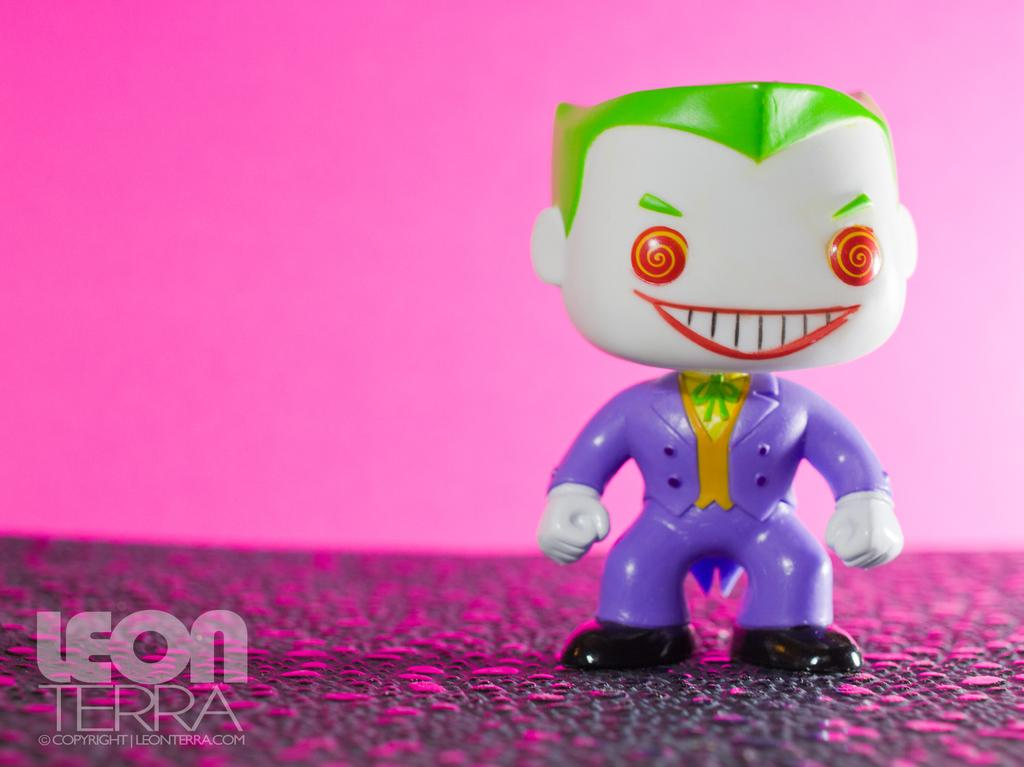What object can be seen in the image? There is a toy in the image. What color is the background of the image? The background of the image has a pink color. How many geese are visible in the image? There are no geese present in the image. Is there a mitten being used by the toy in the image? There is no mitten visible in the image, and the toy's accessories are not mentioned in the provided facts. 